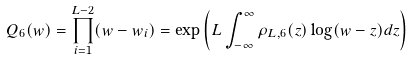<formula> <loc_0><loc_0><loc_500><loc_500>Q _ { 6 } ( w ) = \prod ^ { L - 2 } _ { i = 1 } ( w - w _ { i } ) = \exp \left ( L \int ^ { \infty } _ { - \infty } \rho _ { L , 6 } ( z ) \log ( w - z ) d z \right )</formula> 